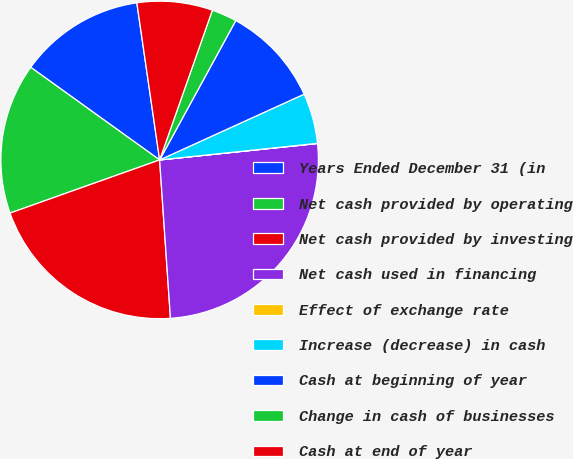<chart> <loc_0><loc_0><loc_500><loc_500><pie_chart><fcel>Years Ended December 31 (in<fcel>Net cash provided by operating<fcel>Net cash provided by investing<fcel>Net cash used in financing<fcel>Effect of exchange rate<fcel>Increase (decrease) in cash<fcel>Cash at beginning of year<fcel>Change in cash of businesses<fcel>Cash at end of year<nl><fcel>12.79%<fcel>15.35%<fcel>20.65%<fcel>25.56%<fcel>0.02%<fcel>5.13%<fcel>10.24%<fcel>2.57%<fcel>7.68%<nl></chart> 